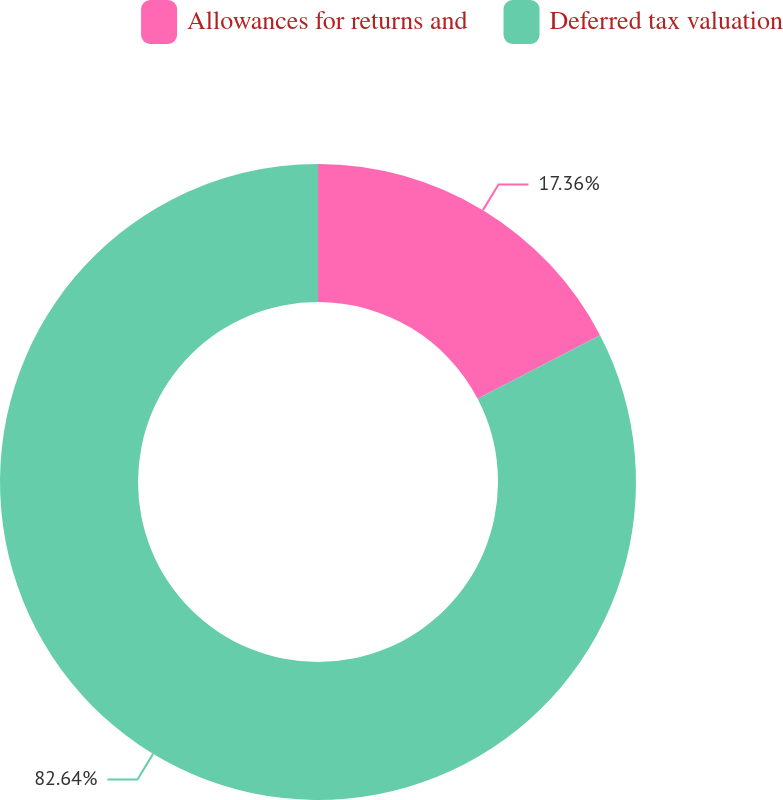Convert chart. <chart><loc_0><loc_0><loc_500><loc_500><pie_chart><fcel>Allowances for returns and<fcel>Deferred tax valuation<nl><fcel>17.36%<fcel>82.64%<nl></chart> 